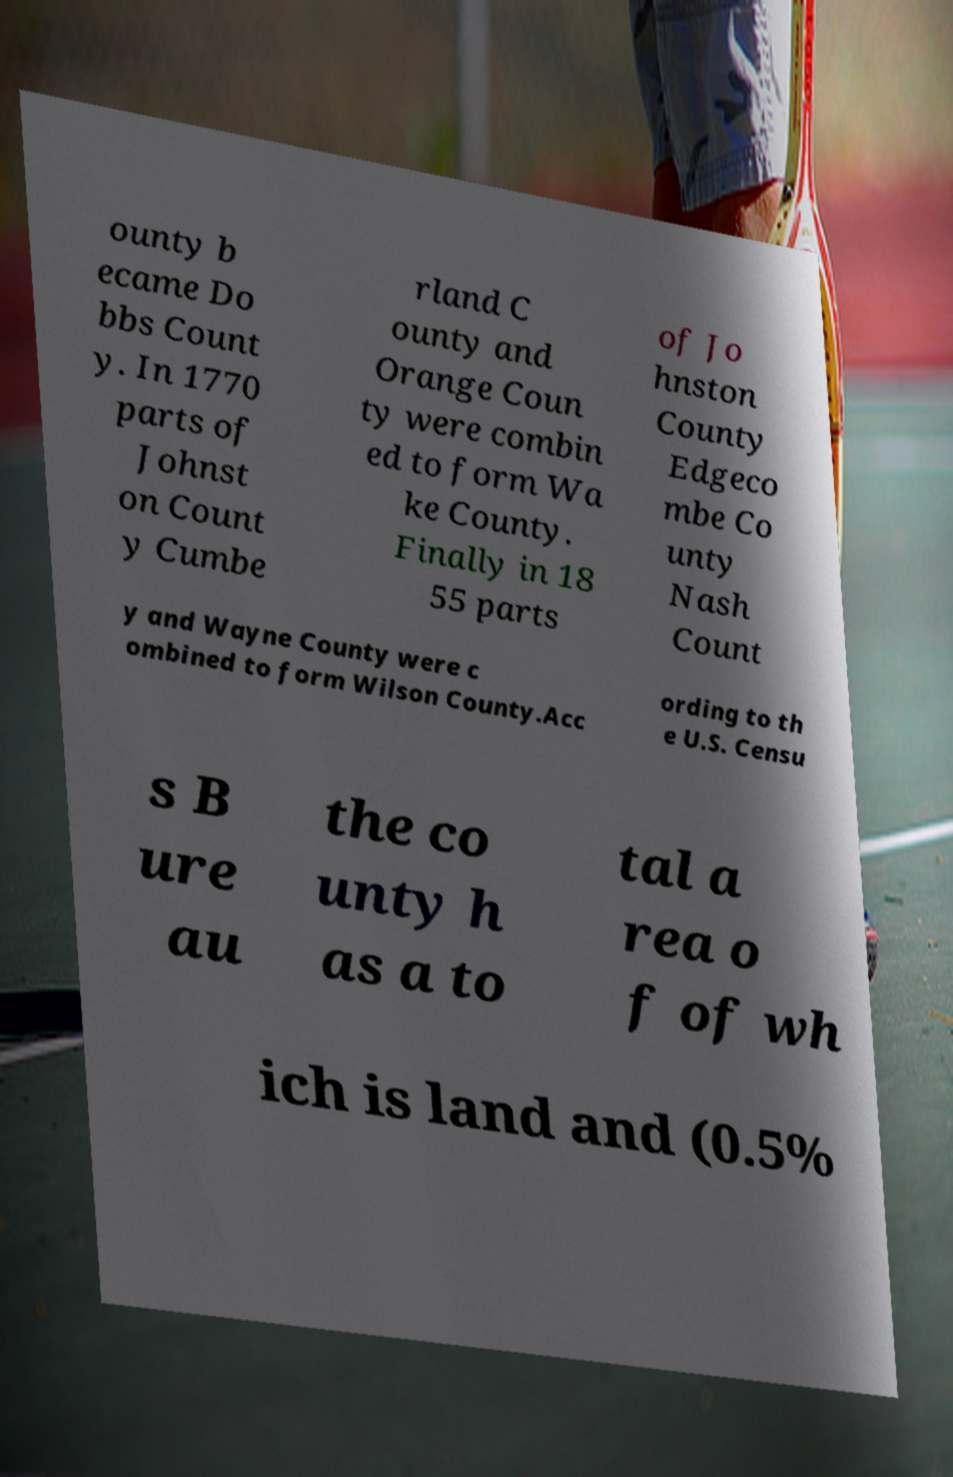Could you assist in decoding the text presented in this image and type it out clearly? ounty b ecame Do bbs Count y. In 1770 parts of Johnst on Count y Cumbe rland C ounty and Orange Coun ty were combin ed to form Wa ke County. Finally in 18 55 parts of Jo hnston County Edgeco mbe Co unty Nash Count y and Wayne County were c ombined to form Wilson County.Acc ording to th e U.S. Censu s B ure au the co unty h as a to tal a rea o f of wh ich is land and (0.5% 